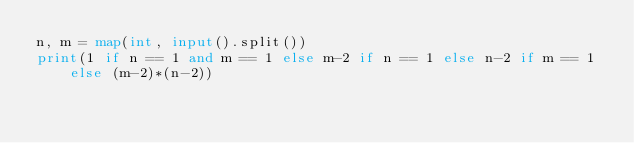Convert code to text. <code><loc_0><loc_0><loc_500><loc_500><_Python_>n, m = map(int, input().split())
print(1 if n == 1 and m == 1 else m-2 if n == 1 else n-2 if m == 1 else (m-2)*(n-2))</code> 